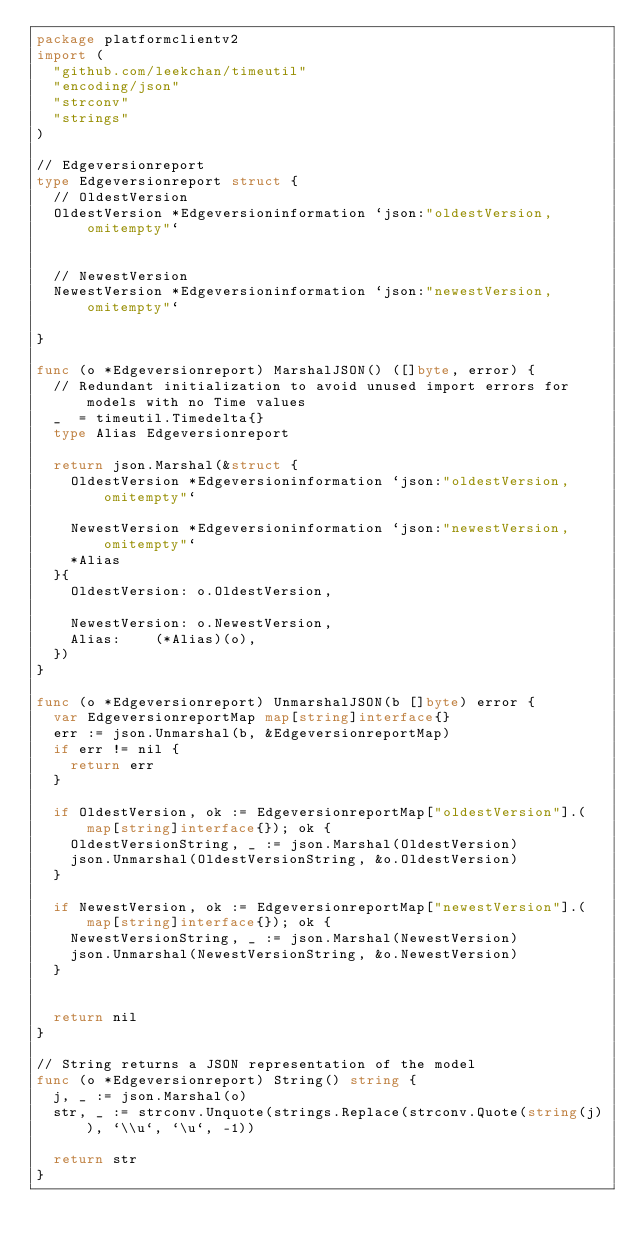<code> <loc_0><loc_0><loc_500><loc_500><_Go_>package platformclientv2
import (
	"github.com/leekchan/timeutil"
	"encoding/json"
	"strconv"
	"strings"
)

// Edgeversionreport
type Edgeversionreport struct { 
	// OldestVersion
	OldestVersion *Edgeversioninformation `json:"oldestVersion,omitempty"`


	// NewestVersion
	NewestVersion *Edgeversioninformation `json:"newestVersion,omitempty"`

}

func (o *Edgeversionreport) MarshalJSON() ([]byte, error) {
	// Redundant initialization to avoid unused import errors for models with no Time values
	_  = timeutil.Timedelta{}
	type Alias Edgeversionreport
	
	return json.Marshal(&struct { 
		OldestVersion *Edgeversioninformation `json:"oldestVersion,omitempty"`
		
		NewestVersion *Edgeversioninformation `json:"newestVersion,omitempty"`
		*Alias
	}{ 
		OldestVersion: o.OldestVersion,
		
		NewestVersion: o.NewestVersion,
		Alias:    (*Alias)(o),
	})
}

func (o *Edgeversionreport) UnmarshalJSON(b []byte) error {
	var EdgeversionreportMap map[string]interface{}
	err := json.Unmarshal(b, &EdgeversionreportMap)
	if err != nil {
		return err
	}
	
	if OldestVersion, ok := EdgeversionreportMap["oldestVersion"].(map[string]interface{}); ok {
		OldestVersionString, _ := json.Marshal(OldestVersion)
		json.Unmarshal(OldestVersionString, &o.OldestVersion)
	}
	
	if NewestVersion, ok := EdgeversionreportMap["newestVersion"].(map[string]interface{}); ok {
		NewestVersionString, _ := json.Marshal(NewestVersion)
		json.Unmarshal(NewestVersionString, &o.NewestVersion)
	}
	

	return nil
}

// String returns a JSON representation of the model
func (o *Edgeversionreport) String() string {
	j, _ := json.Marshal(o)
	str, _ := strconv.Unquote(strings.Replace(strconv.Quote(string(j)), `\\u`, `\u`, -1))

	return str
}
</code> 